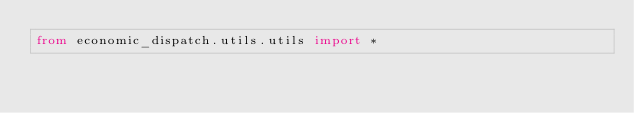Convert code to text. <code><loc_0><loc_0><loc_500><loc_500><_Python_>from economic_dispatch.utils.utils import *</code> 